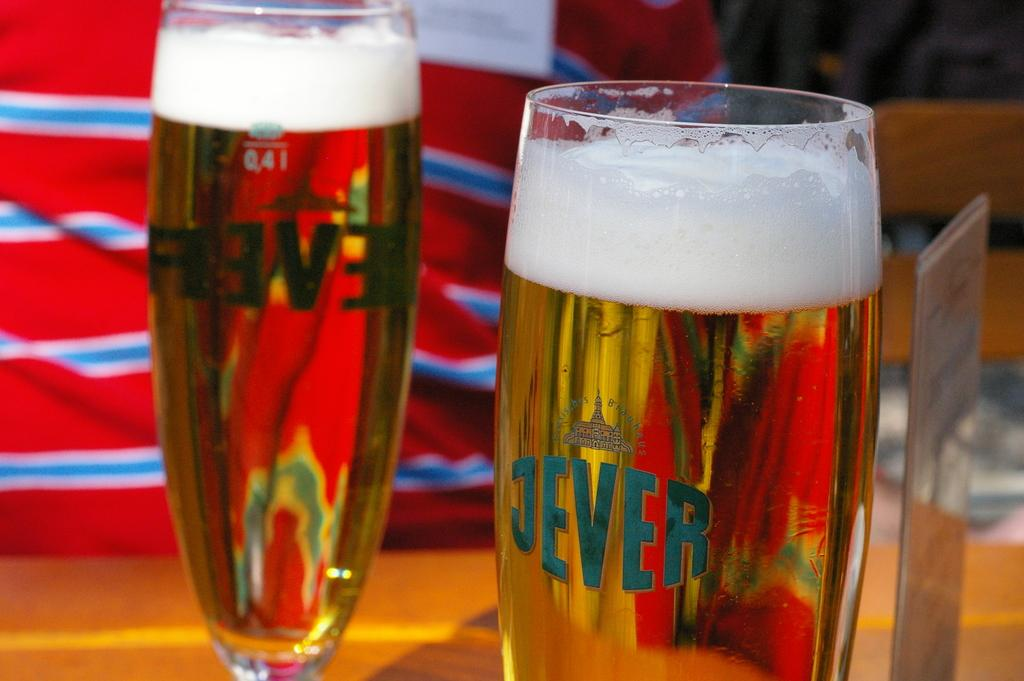<image>
Create a compact narrative representing the image presented. A bottle of beer has been poured in a JEVER glass 